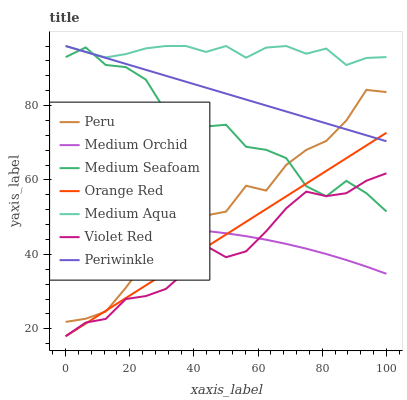Does Violet Red have the minimum area under the curve?
Answer yes or no. Yes. Does Medium Aqua have the maximum area under the curve?
Answer yes or no. Yes. Does Medium Orchid have the minimum area under the curve?
Answer yes or no. No. Does Medium Orchid have the maximum area under the curve?
Answer yes or no. No. Is Orange Red the smoothest?
Answer yes or no. Yes. Is Peru the roughest?
Answer yes or no. Yes. Is Medium Orchid the smoothest?
Answer yes or no. No. Is Medium Orchid the roughest?
Answer yes or no. No. Does Violet Red have the lowest value?
Answer yes or no. Yes. Does Medium Orchid have the lowest value?
Answer yes or no. No. Does Periwinkle have the highest value?
Answer yes or no. Yes. Does Orange Red have the highest value?
Answer yes or no. No. Is Violet Red less than Periwinkle?
Answer yes or no. Yes. Is Medium Aqua greater than Orange Red?
Answer yes or no. Yes. Does Peru intersect Medium Orchid?
Answer yes or no. Yes. Is Peru less than Medium Orchid?
Answer yes or no. No. Is Peru greater than Medium Orchid?
Answer yes or no. No. Does Violet Red intersect Periwinkle?
Answer yes or no. No. 